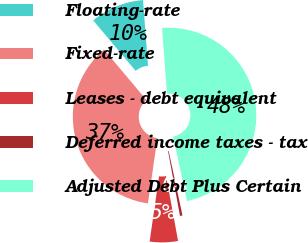<chart> <loc_0><loc_0><loc_500><loc_500><pie_chart><fcel>Floating-rate<fcel>Fixed-rate<fcel>Leases - debt equivalent<fcel>Deferred income taxes - tax<fcel>Adjusted Debt Plus Certain<nl><fcel>9.93%<fcel>36.58%<fcel>5.19%<fcel>0.46%<fcel>47.83%<nl></chart> 